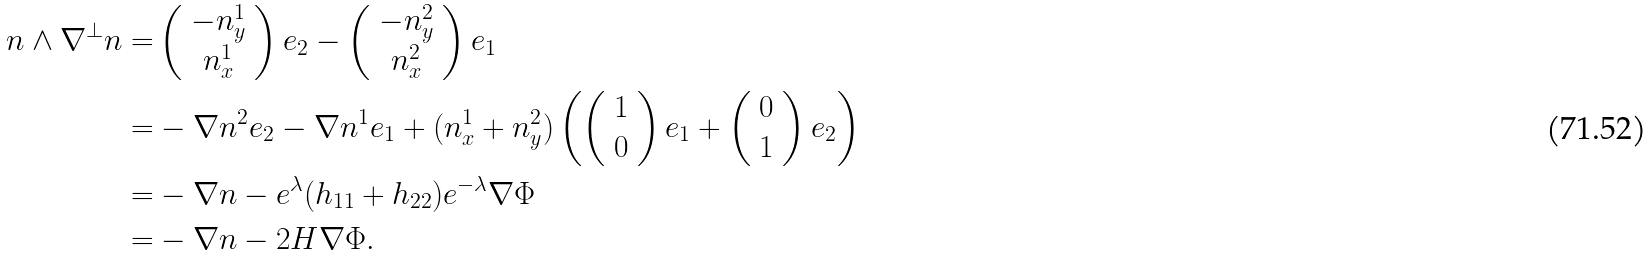<formula> <loc_0><loc_0><loc_500><loc_500>n \wedge \nabla ^ { \perp } n = & \left ( \begin{array} { c } - n _ { y } ^ { 1 } \\ n _ { x } ^ { 1 } \end{array} \right ) e _ { 2 } - \left ( \begin{array} { c } - n _ { y } ^ { 2 } \\ n _ { x } ^ { 2 } \end{array} \right ) e _ { 1 } \\ = & - \nabla n ^ { 2 } e _ { 2 } - \nabla n ^ { 1 } e _ { 1 } + ( n _ { x } ^ { 1 } + n _ { y } ^ { 2 } ) \left ( \left ( \begin{array} { c } 1 \\ 0 \end{array} \right ) e _ { 1 } + \left ( \begin{array} { c } 0 \\ 1 \end{array} \right ) e _ { 2 } \right ) \\ = & - \nabla n - e ^ { \lambda } ( h _ { 1 1 } + h _ { 2 2 } ) e ^ { - \lambda } \nabla \Phi \\ = & - \nabla n - 2 H \nabla \Phi .</formula> 